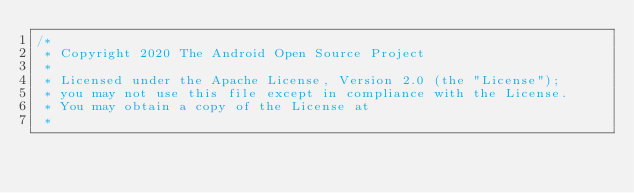Convert code to text. <code><loc_0><loc_0><loc_500><loc_500><_Kotlin_>/*
 * Copyright 2020 The Android Open Source Project
 *
 * Licensed under the Apache License, Version 2.0 (the "License");
 * you may not use this file except in compliance with the License.
 * You may obtain a copy of the License at
 *</code> 